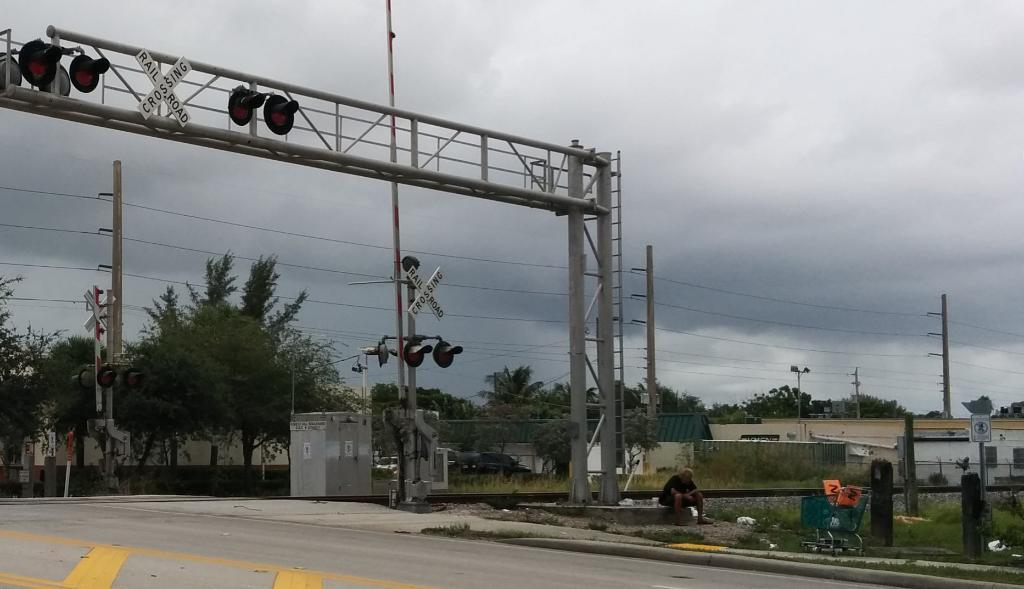Provide a one-sentence caption for the provided image. Two strips of wood in the shape of an x say railroad crossing. 